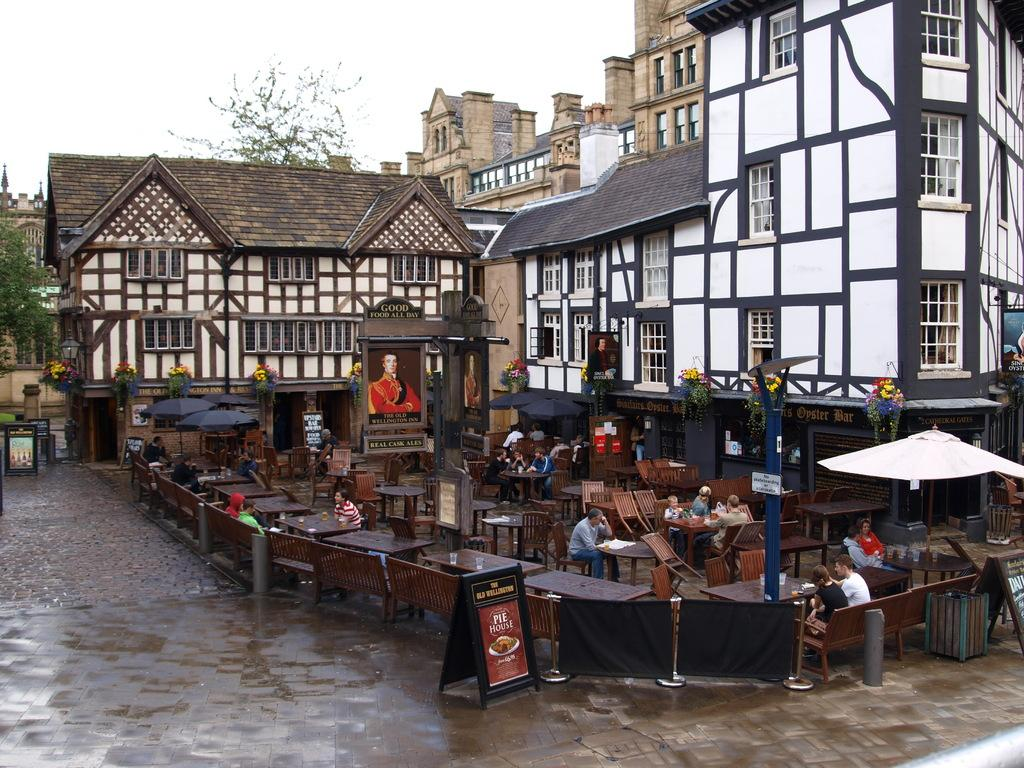<image>
Write a terse but informative summary of the picture. An outdoor cafe at the Old Willington Inn in the rain 